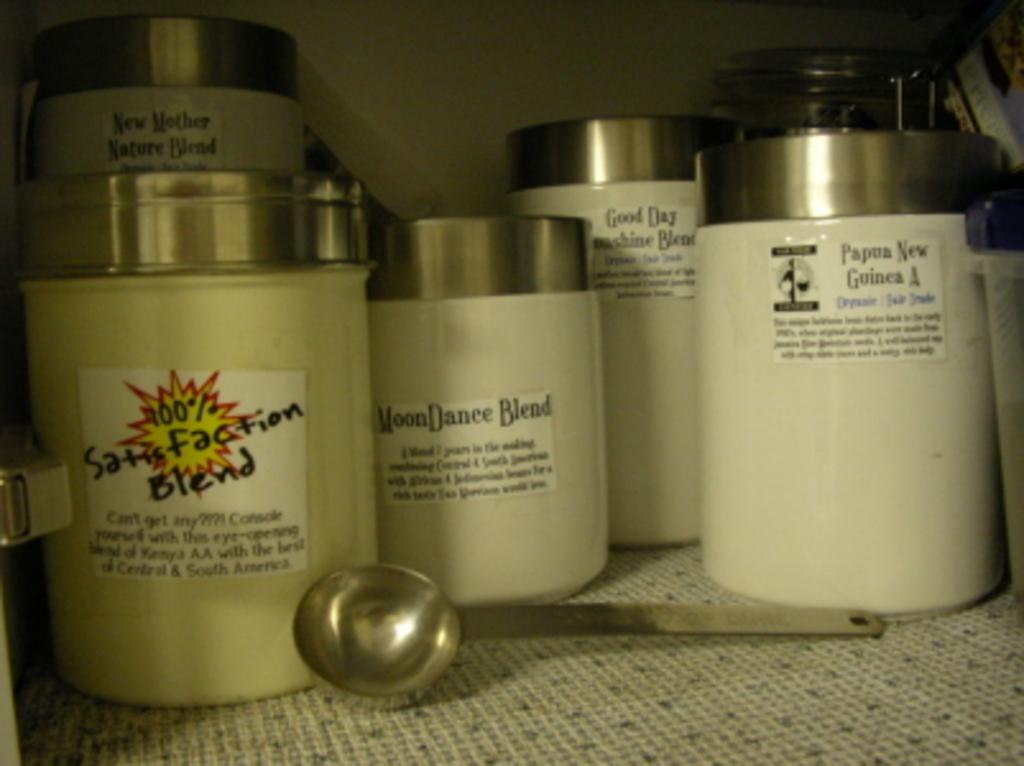<image>
Describe the image concisely. white cannisters with silver tops with the front one called 100% satisfaction blend 